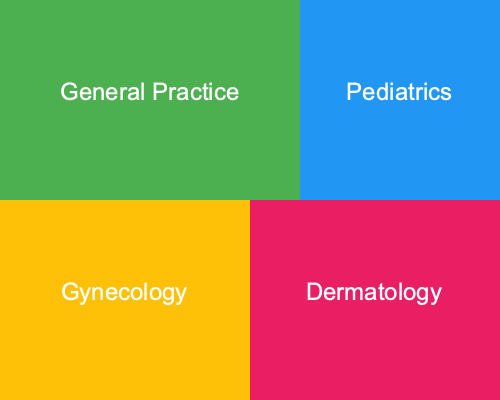Based on the treemap showing the distribution of medical specialties at Belmont Hill Surgery, which specialty appears to have the largest representation, and approximately what percentage of the total area does it occupy? To determine the largest specialty and its approximate percentage, we need to follow these steps:

1. Identify the largest rectangle in the treemap:
   The largest rectangle is in the top-left corner, labeled "General Practice".

2. Calculate the total area of the treemap:
   The treemap is a 500x400 pixel rectangle, so the total area is 500 * 400 = 200,000 square pixels.

3. Calculate the area of the General Practice rectangle:
   This rectangle is 300x200 pixels, so its area is 300 * 200 = 60,000 square pixels.

4. Calculate the percentage:
   Percentage = (Area of General Practice / Total Area) * 100
   = (60,000 / 200,000) * 100
   = 0.3 * 100
   = 30%

Therefore, General Practice occupies approximately 30% of the total area in the treemap.
Answer: General Practice, 30% 